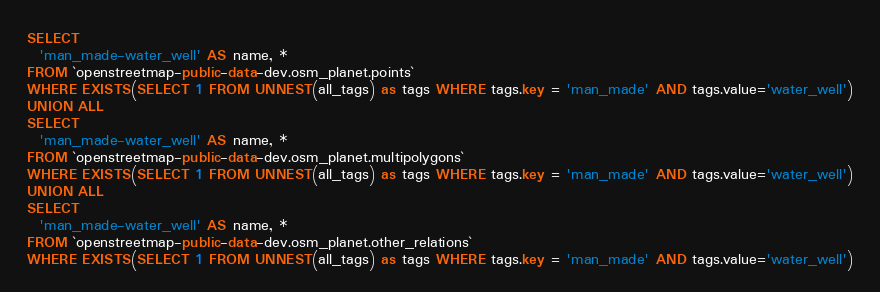Convert code to text. <code><loc_0><loc_0><loc_500><loc_500><_SQL_>SELECT
  'man_made-water_well' AS name, *
FROM `openstreetmap-public-data-dev.osm_planet.points`
WHERE EXISTS(SELECT 1 FROM UNNEST(all_tags) as tags WHERE tags.key = 'man_made' AND tags.value='water_well')
UNION ALL
SELECT
  'man_made-water_well' AS name, *
FROM `openstreetmap-public-data-dev.osm_planet.multipolygons`
WHERE EXISTS(SELECT 1 FROM UNNEST(all_tags) as tags WHERE tags.key = 'man_made' AND tags.value='water_well')
UNION ALL
SELECT
  'man_made-water_well' AS name, *
FROM `openstreetmap-public-data-dev.osm_planet.other_relations`
WHERE EXISTS(SELECT 1 FROM UNNEST(all_tags) as tags WHERE tags.key = 'man_made' AND tags.value='water_well')

</code> 